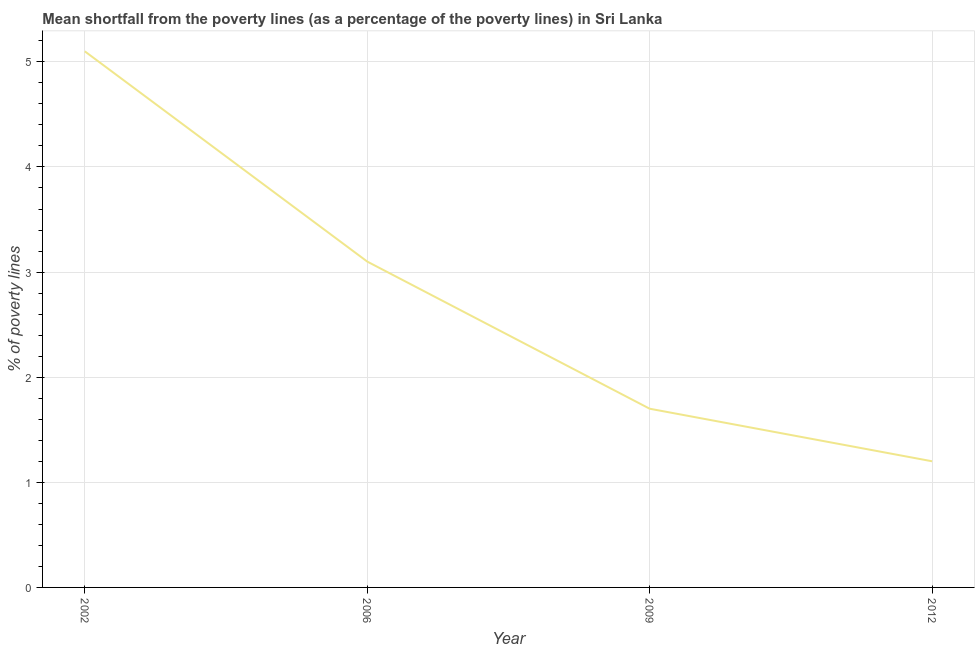Across all years, what is the maximum poverty gap at national poverty lines?
Your answer should be very brief. 5.1. Across all years, what is the minimum poverty gap at national poverty lines?
Provide a short and direct response. 1.2. In which year was the poverty gap at national poverty lines maximum?
Make the answer very short. 2002. In which year was the poverty gap at national poverty lines minimum?
Give a very brief answer. 2012. What is the sum of the poverty gap at national poverty lines?
Your answer should be very brief. 11.1. What is the difference between the poverty gap at national poverty lines in 2009 and 2012?
Ensure brevity in your answer.  0.5. What is the average poverty gap at national poverty lines per year?
Provide a short and direct response. 2.77. Do a majority of the years between 2009 and 2012 (inclusive) have poverty gap at national poverty lines greater than 1 %?
Your answer should be compact. Yes. What is the ratio of the poverty gap at national poverty lines in 2006 to that in 2009?
Your response must be concise. 1.82. Is the poverty gap at national poverty lines in 2002 less than that in 2009?
Ensure brevity in your answer.  No. What is the difference between the highest and the second highest poverty gap at national poverty lines?
Provide a short and direct response. 2. Is the sum of the poverty gap at national poverty lines in 2006 and 2012 greater than the maximum poverty gap at national poverty lines across all years?
Your answer should be compact. No. What is the difference between the highest and the lowest poverty gap at national poverty lines?
Keep it short and to the point. 3.9. In how many years, is the poverty gap at national poverty lines greater than the average poverty gap at national poverty lines taken over all years?
Give a very brief answer. 2. Does the poverty gap at national poverty lines monotonically increase over the years?
Your answer should be very brief. No. How many lines are there?
Offer a very short reply. 1. What is the difference between two consecutive major ticks on the Y-axis?
Make the answer very short. 1. Does the graph contain any zero values?
Make the answer very short. No. What is the title of the graph?
Offer a terse response. Mean shortfall from the poverty lines (as a percentage of the poverty lines) in Sri Lanka. What is the label or title of the Y-axis?
Give a very brief answer. % of poverty lines. What is the difference between the % of poverty lines in 2002 and 2009?
Your response must be concise. 3.4. What is the difference between the % of poverty lines in 2006 and 2009?
Ensure brevity in your answer.  1.4. What is the difference between the % of poverty lines in 2006 and 2012?
Ensure brevity in your answer.  1.9. What is the difference between the % of poverty lines in 2009 and 2012?
Provide a succinct answer. 0.5. What is the ratio of the % of poverty lines in 2002 to that in 2006?
Keep it short and to the point. 1.65. What is the ratio of the % of poverty lines in 2002 to that in 2009?
Ensure brevity in your answer.  3. What is the ratio of the % of poverty lines in 2002 to that in 2012?
Offer a terse response. 4.25. What is the ratio of the % of poverty lines in 2006 to that in 2009?
Ensure brevity in your answer.  1.82. What is the ratio of the % of poverty lines in 2006 to that in 2012?
Provide a succinct answer. 2.58. What is the ratio of the % of poverty lines in 2009 to that in 2012?
Your response must be concise. 1.42. 